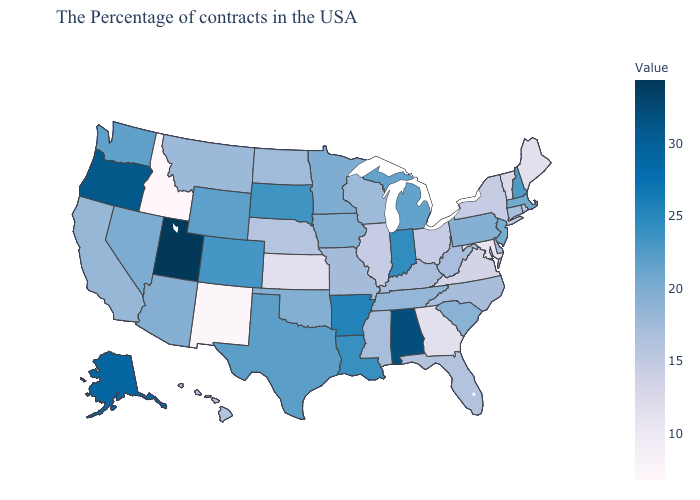Does Utah have the highest value in the USA?
Give a very brief answer. Yes. Is the legend a continuous bar?
Give a very brief answer. Yes. Which states have the lowest value in the USA?
Keep it brief. Idaho. Among the states that border Montana , which have the highest value?
Quick response, please. South Dakota. Does Idaho have the lowest value in the West?
Give a very brief answer. Yes. Does Idaho have the lowest value in the USA?
Answer briefly. Yes. Does Idaho have the lowest value in the USA?
Short answer required. Yes. 